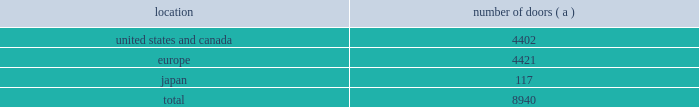Table of contents worldwide distribution channels the table presents the number of doors by geographic location , in which ralph lauren-branded products distributed by our wholesale segment were sold to consumers in our primary channels of distribution as of april 3 , 2010 : number of location doors ( a ) .
( a ) in asia-pacific , our products are primarily distributed through concessions-based sales arrangements .
In addition , american living and chaps-branded products distributed by our wholesale segment were sold domestically through approximately 1700 doors as of april 3 , 2010 .
We have five key department-store customers that generate significant sales volume .
For fiscal 2010 , these customers in the aggregate accounted for approximately 45% ( 45 % ) of all wholesale revenues , with macy 2019s , inc .
Representing approximately 18% ( 18 % ) of these revenues .
Our product brands are sold primarily through their own sales forces .
Our wholesale segment maintains its primary showrooms in new york city .
In addition , we maintain regional showrooms in atlanta , chicago , dallas , milan , paris , london , munich , madrid and stockholm .
Shop-within-shops .
As a critical element of our distribution to department stores , we and our licensing partners utilize shop- within-shops to enhance brand recognition , to permit more complete merchandising of our lines by the department stores and to differentiate the presentation of products .
Shop-within-shops fixed assets primarily include items such as customized freestanding fixtures , wall cases and components , decorative items and flooring .
As of april 3 , 2010 , we had approximately 14000 shop-within-shops dedicated to our ralph lauren-branded wholesale products worldwide .
Excluding significantly larger shop-within-shops in key department store locations , the size of our shop-within-shops typically ranges from approximately 300 to 6000 square feet .
We normally share in the cost of these shop-within-shops with our wholesale customers .
Basic stock replenishment program .
Basic products such as knit shirts , chino pants and oxford cloth shirts can be ordered at any time through our basic stock replenishment programs .
We generally ship these products within three-to-five days of order receipt .
Our retail segment as of april 3 , 2010 , our retail segment consisted of 179 full-price retail stores and 171 factory stores worldwide , totaling approximately 2.6 million square feet , 281 concessions-based shop-within-shops and two e-commerce websites .
The extension of our direct-to-consumer reach is a primary long-term strategic goal .
Full-price retail stores our full-price retail stores reinforce the luxury image and distinct sensibility of our brands and feature exclusive lines that are not sold in domestic department stores .
We opened 3 new full-price stores and closed 3 full-price stores in fiscal 2010 .
In addition , we assumed 16 full-price stores in connection with the asia-pacific .
What percentage of doors in the wholesale segment as of april 3 , 2010 where in the united states and canada geography? 
Computations: (4402 / 8940)
Answer: 0.49239. 